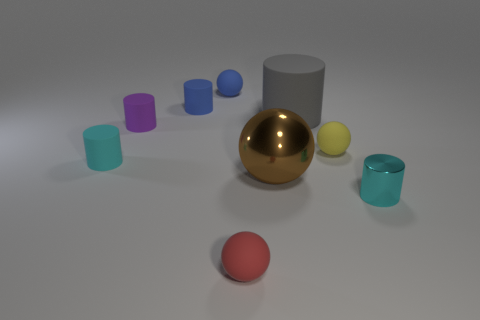What number of other objects are the same shape as the small red object?
Your answer should be compact. 3. There is a tiny cyan thing that is behind the small metal cylinder; what is its shape?
Offer a very short reply. Cylinder. Do the yellow object in front of the gray rubber cylinder and the tiny blue object to the right of the blue cylinder have the same shape?
Offer a terse response. Yes. Are there the same number of small cylinders that are to the right of the cyan rubber thing and small rubber balls?
Your answer should be very brief. Yes. Is there anything else that is the same size as the cyan metallic cylinder?
Provide a short and direct response. Yes. There is a brown object that is the same shape as the small red matte object; what is it made of?
Offer a very short reply. Metal. There is a big object in front of the rubber ball that is right of the red ball; what shape is it?
Your answer should be compact. Sphere. Is the material of the tiny cyan object right of the large brown metallic sphere the same as the big brown thing?
Provide a succinct answer. Yes. Is the number of small spheres on the right side of the small purple thing the same as the number of small objects left of the big ball?
Ensure brevity in your answer.  No. What material is the small cylinder that is the same color as the small metallic object?
Offer a terse response. Rubber. 